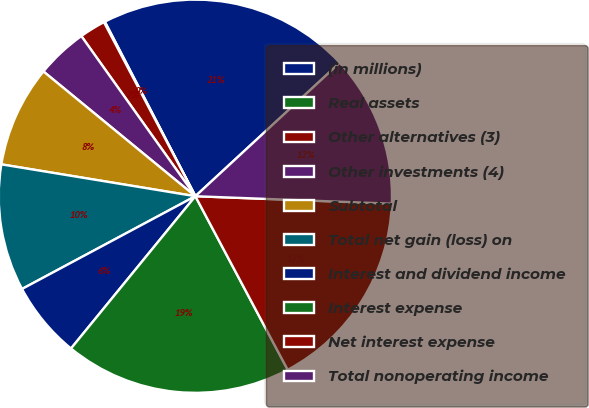Convert chart to OTSL. <chart><loc_0><loc_0><loc_500><loc_500><pie_chart><fcel>(in millions)<fcel>Real assets<fcel>Other alternatives (3)<fcel>Other investments (4)<fcel>Subtotal<fcel>Total net gain (loss) on<fcel>Interest and dividend income<fcel>Interest expense<fcel>Net interest expense<fcel>Total nonoperating income<nl><fcel>20.74%<fcel>0.08%<fcel>2.15%<fcel>4.21%<fcel>8.35%<fcel>10.41%<fcel>6.28%<fcel>18.68%<fcel>16.61%<fcel>12.48%<nl></chart> 